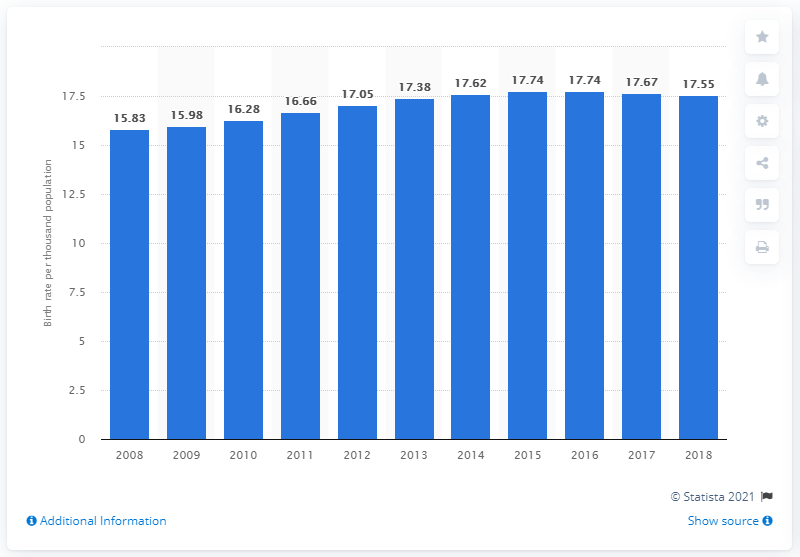Give some essential details in this illustration. In 2018, the crude birth rate in Lebanon was 17.55. 